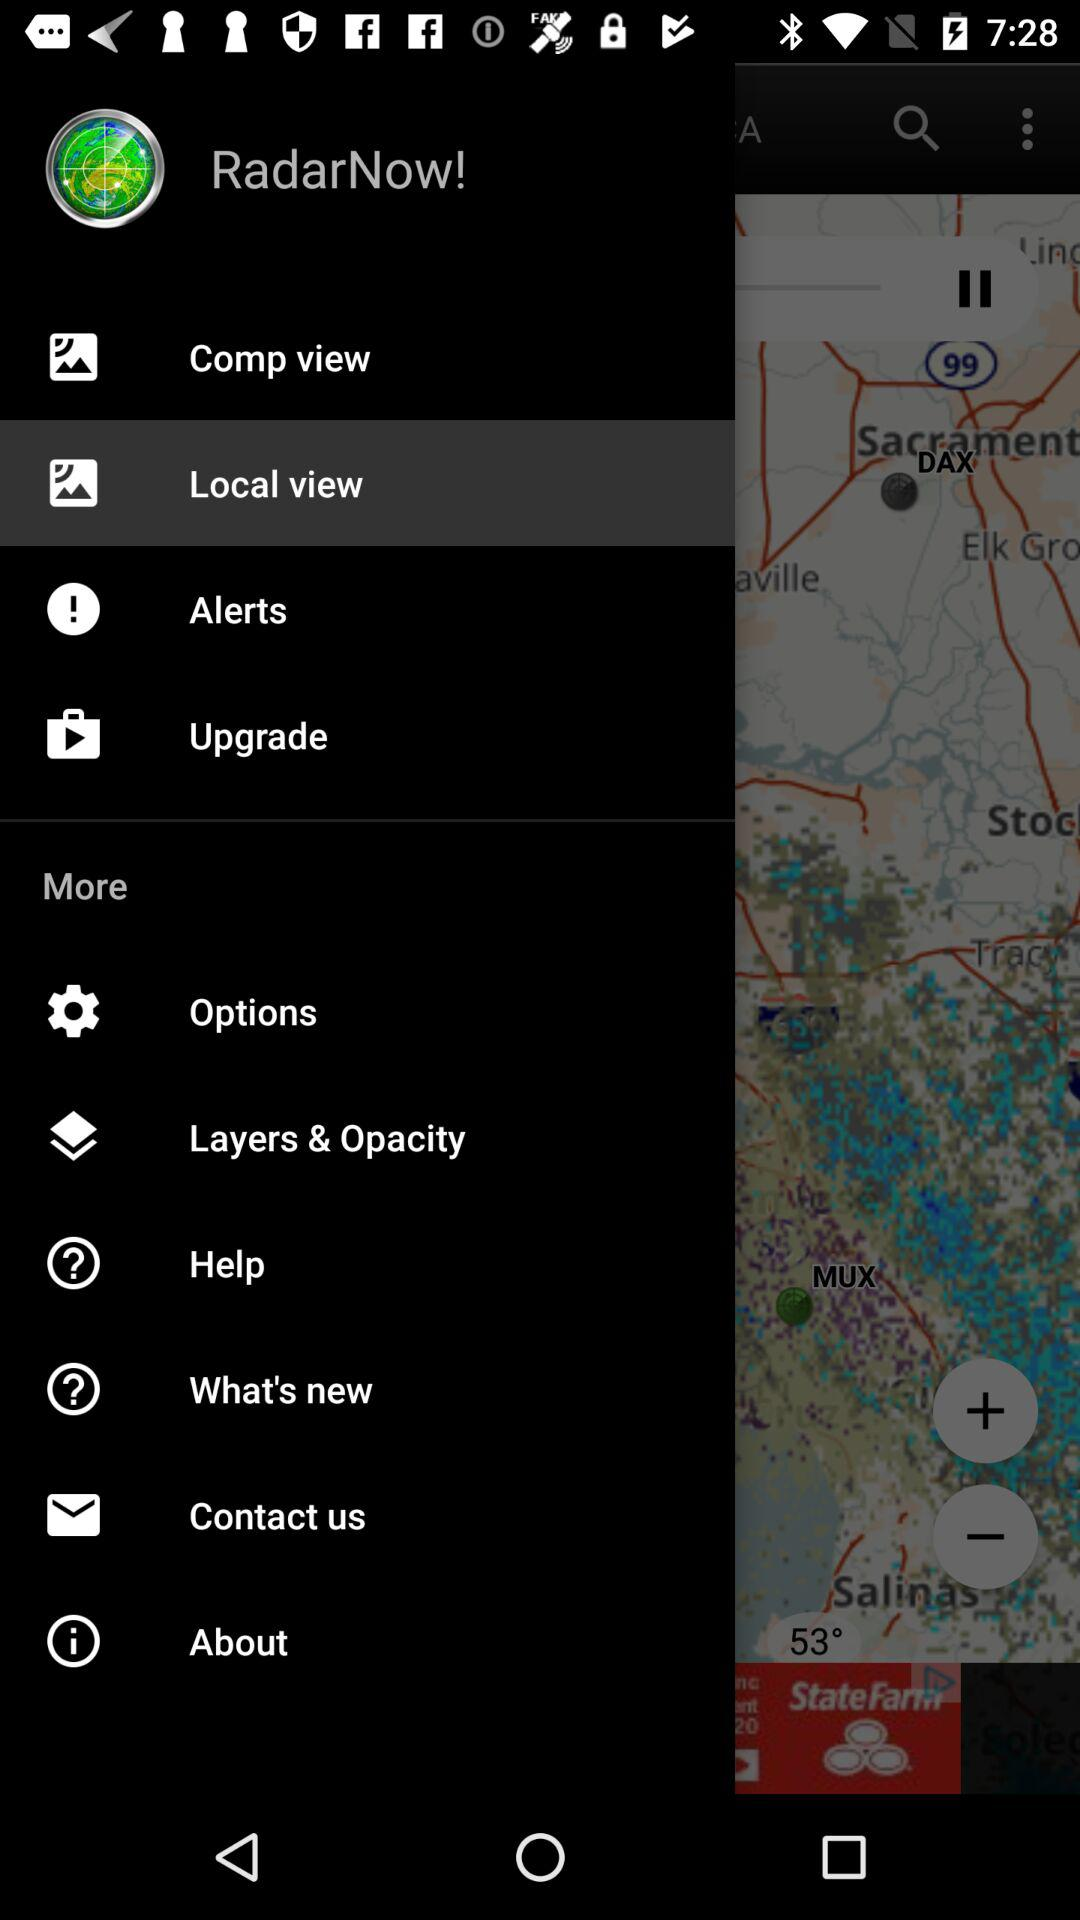What is the name of the application? The name of the application is "RadarNow!". 